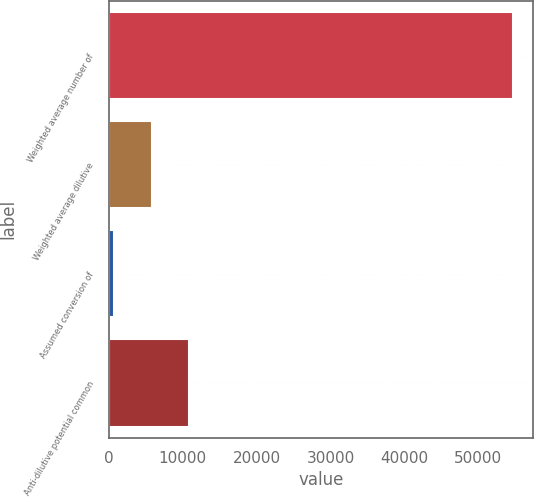<chart> <loc_0><loc_0><loc_500><loc_500><bar_chart><fcel>Weighted average number of<fcel>Weighted average dilutive<fcel>Assumed conversion of<fcel>Anti-dilutive potential common<nl><fcel>54702.2<fcel>5777.2<fcel>729<fcel>10825.4<nl></chart> 